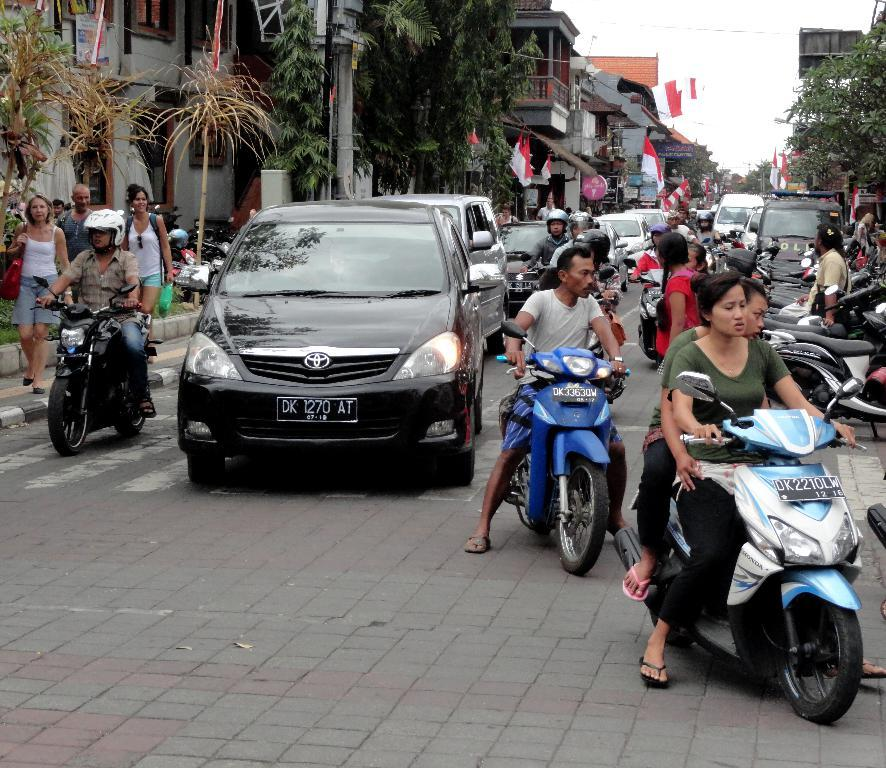What are the people in the image doing? The people in the image are riding bikes on the road. What other vehicles are present in the image? There are cars in the image. What type of transportation is also visible in the image? There are bikes in the image. Can you describe the people in the image? There are people in the image who are riding bikes. What type of natural elements can be seen in the image? There are plants and trees in the image. What type of man-made structures are present in the image? There are buildings in the image. What type of symbols can be seen in the image? There are flags in the image. What type of signage is present in the image? There are boards in the image. What is visible in the background of the image? The sky is visible in the background of the image. Is there any quicksand present in the image? No, there is no quicksand present in the image. Can you tell me how many people are guiding the bikes in the image? There is no mention of people guiding the bikes in the image, as the people are riding the bikes themselves. 